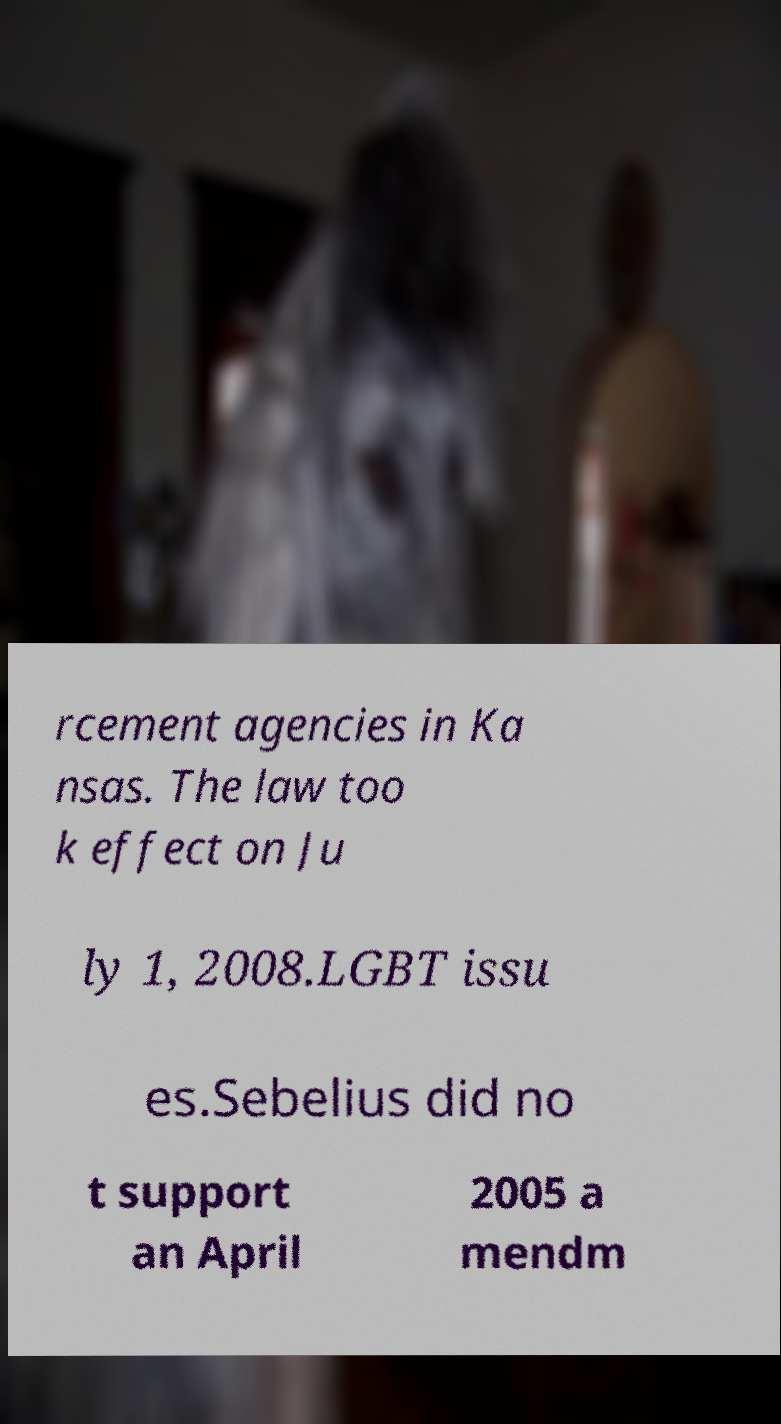For documentation purposes, I need the text within this image transcribed. Could you provide that? rcement agencies in Ka nsas. The law too k effect on Ju ly 1, 2008.LGBT issu es.Sebelius did no t support an April 2005 a mendm 